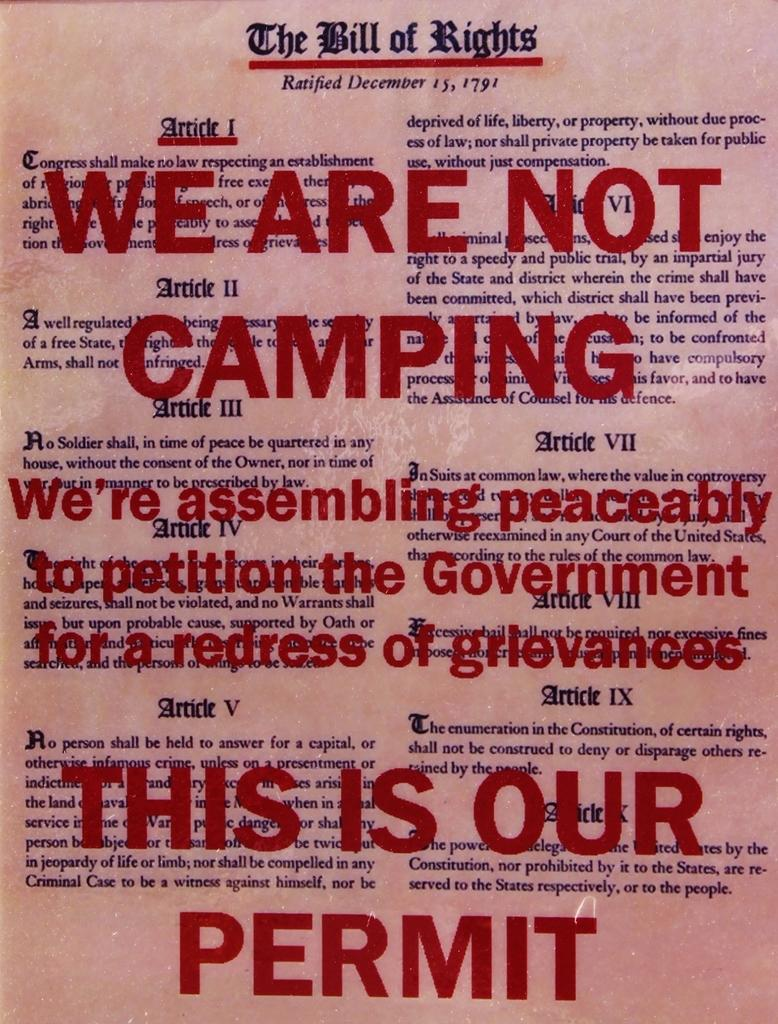Provide a one-sentence caption for the provided image. A copy of the bill of rights has red letters written over it. 